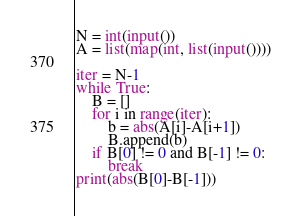<code> <loc_0><loc_0><loc_500><loc_500><_Python_>N = int(input())
A = list(map(int, list(input())))

iter = N-1
while True:
    B = []
    for i in range(iter):
        b = abs(A[i]-A[i+1])
        B.append(b)
    if B[0] != 0 and B[-1] != 0:
        break
print(abs(B[0]-B[-1]))
</code> 